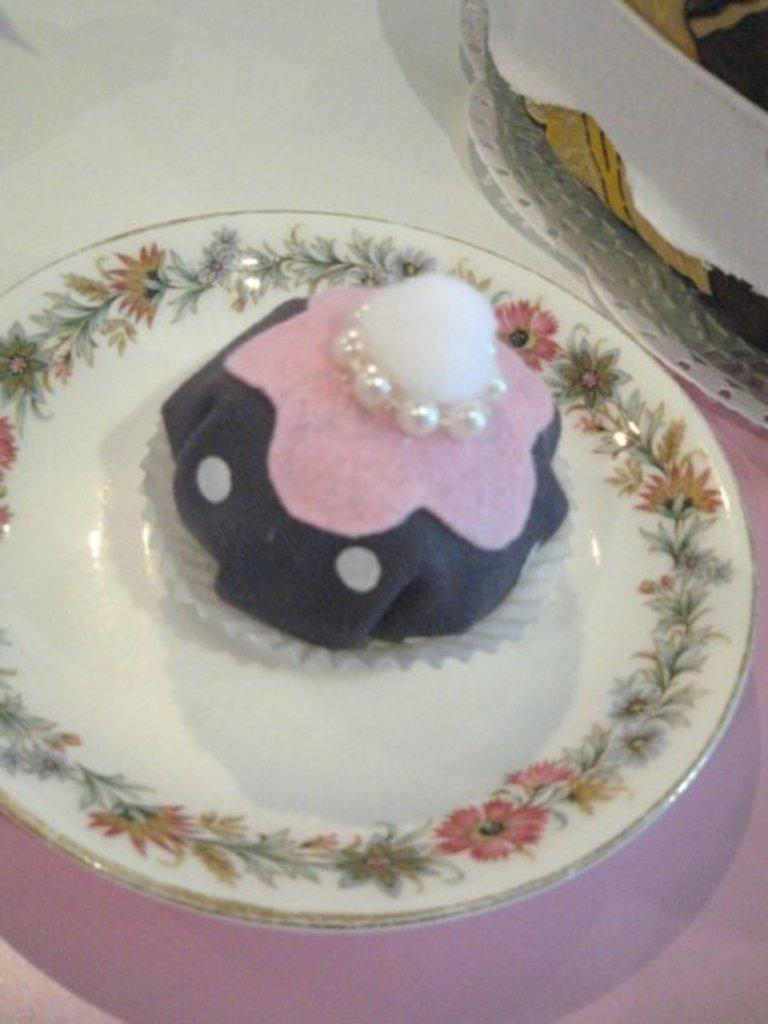What piece of furniture is present in the image? There is a table in the image. How many plates are on the table? There are two plates on the table. What is on one of the plates? One of the plates contains a cake. What type of screw is holding the cake in place on the plate? There is no screw present in the image; the cake is simply placed on the plate. 